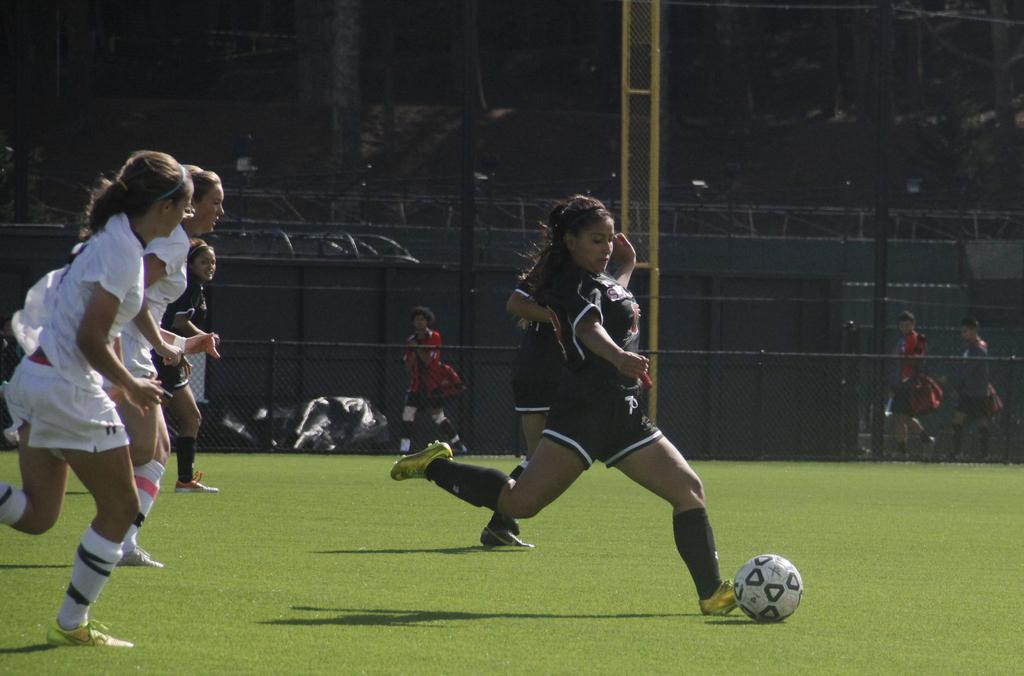What is happening in the image involving a group of girls? The girls are playing football in the image. Where is the football game taking place? The football game is taking place on a ground. What can be seen in the background of the image? There is a fence visible in the image. Can you describe any other objects or elements in the image? There are other unspecified objects or elements in the image. How many passengers are sitting in the garden in the image? There is no garden or passengers present in the image; it features a group of girls playing football on a ground. 